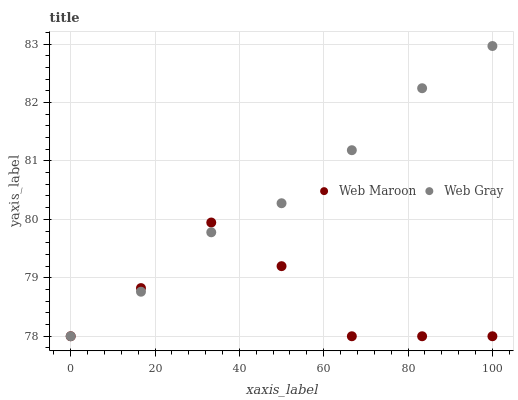Does Web Maroon have the minimum area under the curve?
Answer yes or no. Yes. Does Web Gray have the maximum area under the curve?
Answer yes or no. Yes. Does Web Maroon have the maximum area under the curve?
Answer yes or no. No. Is Web Gray the smoothest?
Answer yes or no. Yes. Is Web Maroon the roughest?
Answer yes or no. Yes. Is Web Maroon the smoothest?
Answer yes or no. No. Does Web Gray have the lowest value?
Answer yes or no. Yes. Does Web Gray have the highest value?
Answer yes or no. Yes. Does Web Maroon have the highest value?
Answer yes or no. No. Does Web Gray intersect Web Maroon?
Answer yes or no. Yes. Is Web Gray less than Web Maroon?
Answer yes or no. No. Is Web Gray greater than Web Maroon?
Answer yes or no. No. 